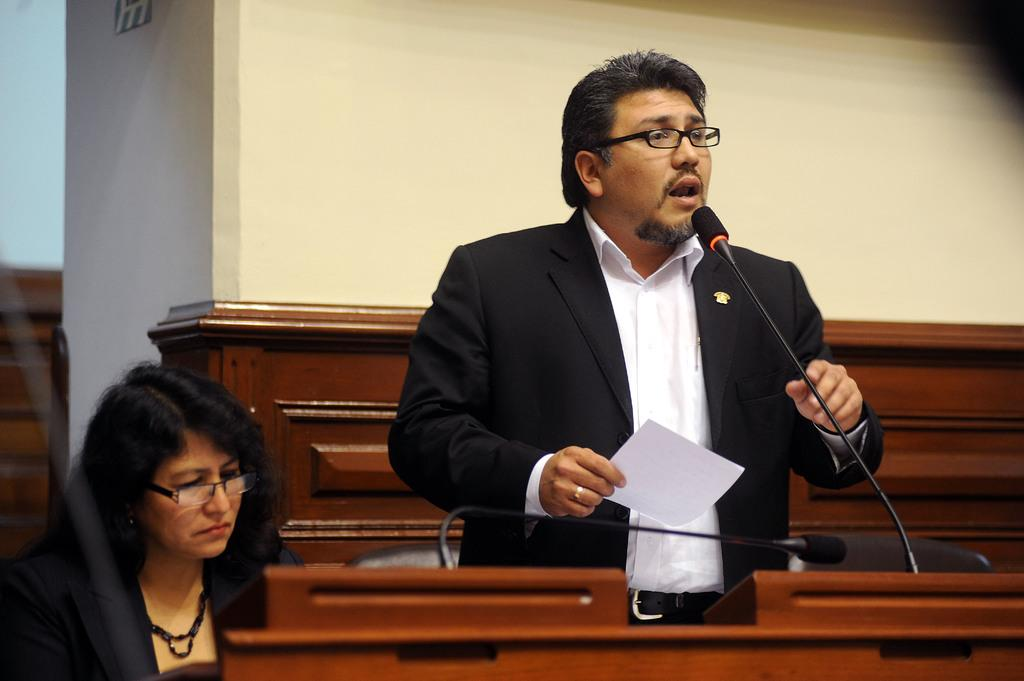What objects are in the foreground of the picture? There are tables, chairs, a microphone, a woman, and a man in the foreground of the picture. What is the man in the foreground of the picture doing? The man is standing, holding a paper, and speaking. What can be seen in the background of the picture? There is a well in the background of the picture. What type of collar can be seen on the woman in the picture? There is no collar visible on the woman in the picture. What is the woman's opinion on the topic being discussed by the man? The image does not provide any information about the woman's opinion on the topic being discussed by the man. How many beds are visible in the picture? There are no beds visible in the picture. 